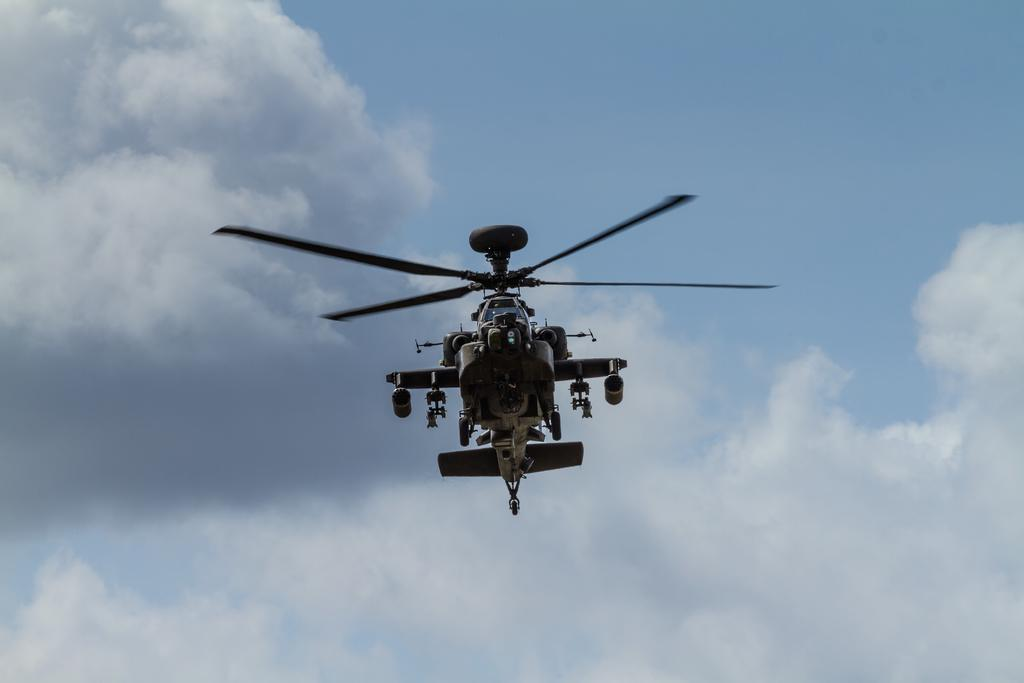What is the main subject in the center of the image? There is a helicopter in the center of the image. What can be seen in the background of the image? There are clouds in the sky in the background of the image. What hobbies does the mom enjoy in the image? There is no mention of a mom or any hobbies in the image; it only features a helicopter and clouds in the sky. 